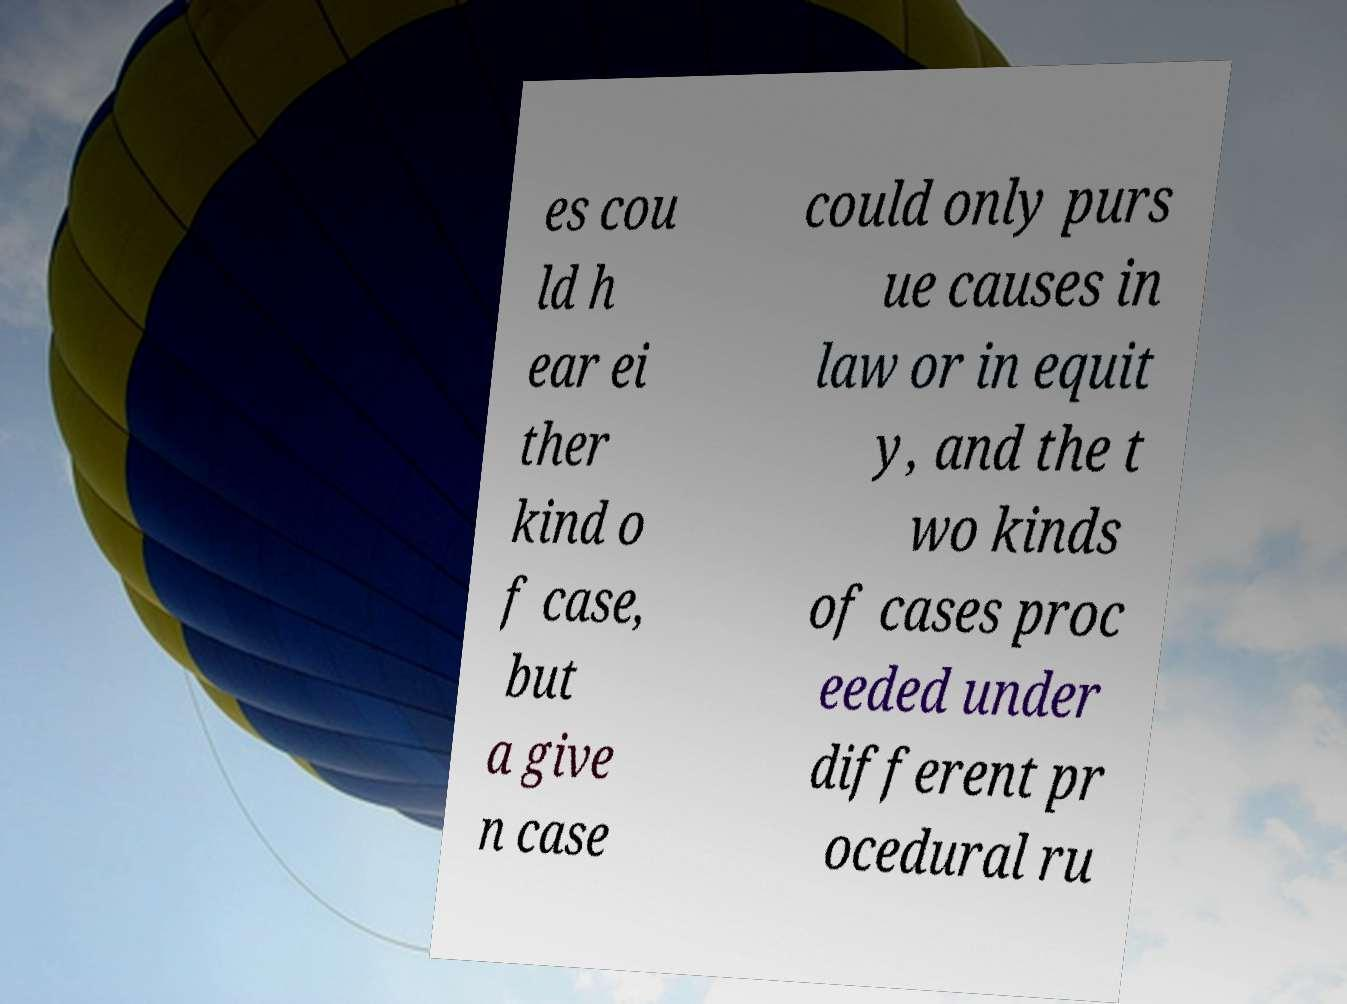Please identify and transcribe the text found in this image. es cou ld h ear ei ther kind o f case, but a give n case could only purs ue causes in law or in equit y, and the t wo kinds of cases proc eeded under different pr ocedural ru 